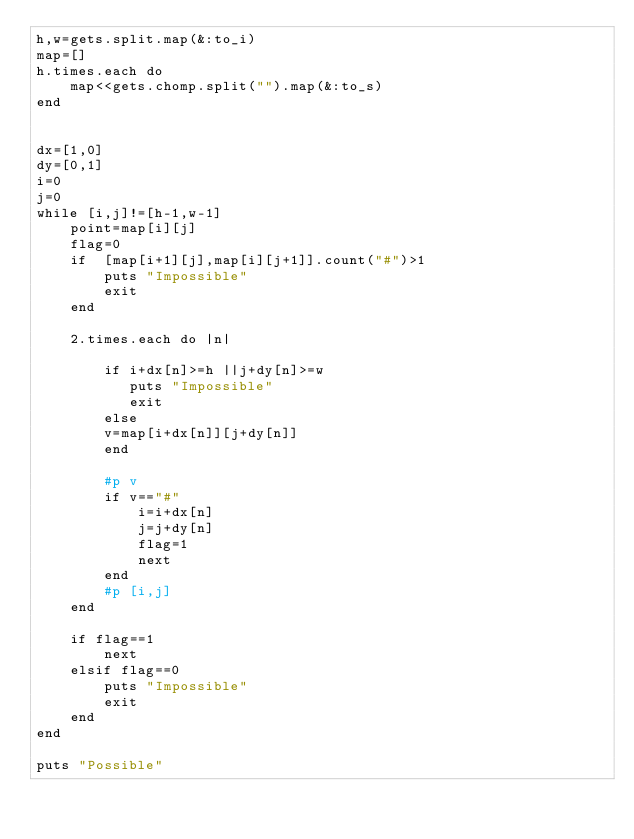Convert code to text. <code><loc_0><loc_0><loc_500><loc_500><_Ruby_>h,w=gets.split.map(&:to_i)
map=[]
h.times.each do
    map<<gets.chomp.split("").map(&:to_s)
end


dx=[1,0]
dy=[0,1]
i=0
j=0
while [i,j]!=[h-1,w-1]
    point=map[i][j]
    flag=0
    if  [map[i+1][j],map[i][j+1]].count("#")>1
        puts "Impossible"
        exit
    end
        
    2.times.each do |n|
        
        if i+dx[n]>=h ||j+dy[n]>=w
           puts "Impossible"
           exit
        else
        v=map[i+dx[n]][j+dy[n]]
        end
       
        #p v
        if v=="#"
            i=i+dx[n]
            j=j+dy[n]
            flag=1
            next
        end
        #p [i,j]
    end
    
    if flag==1
        next
    elsif flag==0
        puts "Impossible"
        exit
    end
end

puts "Possible"</code> 